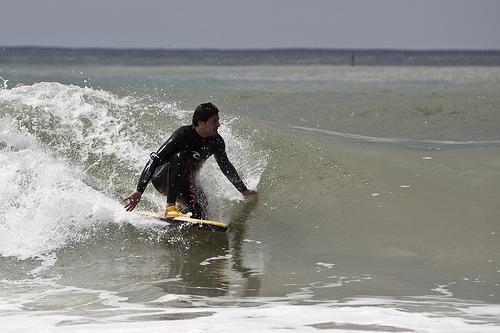How many people?
Give a very brief answer. 1. 